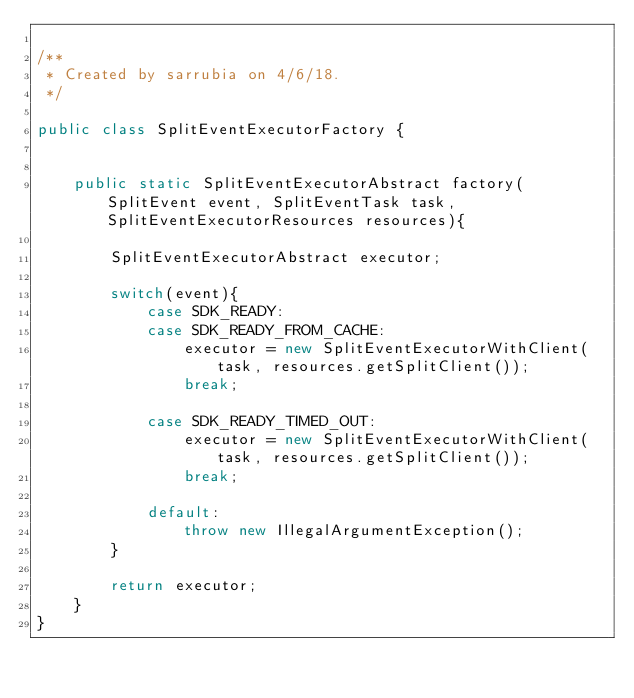<code> <loc_0><loc_0><loc_500><loc_500><_Java_>
/**
 * Created by sarrubia on 4/6/18.
 */

public class SplitEventExecutorFactory {


    public static SplitEventExecutorAbstract factory(SplitEvent event, SplitEventTask task, SplitEventExecutorResources resources){

        SplitEventExecutorAbstract executor;

        switch(event){
            case SDK_READY:
            case SDK_READY_FROM_CACHE:
                executor = new SplitEventExecutorWithClient(task, resources.getSplitClient());
                break;

            case SDK_READY_TIMED_OUT:
                executor = new SplitEventExecutorWithClient(task, resources.getSplitClient());
                break;

            default:
                throw new IllegalArgumentException();
        }

        return executor;
    }
}
</code> 